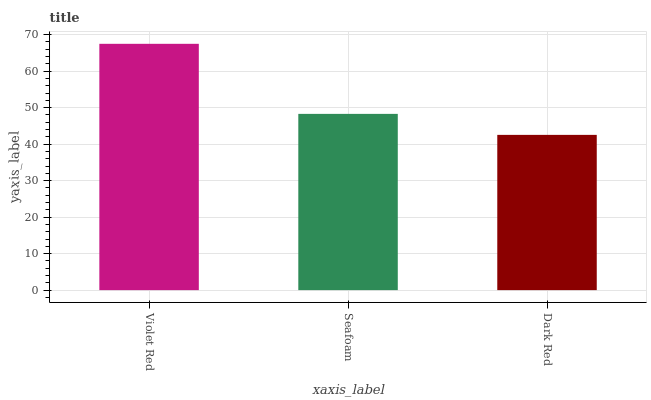Is Dark Red the minimum?
Answer yes or no. Yes. Is Violet Red the maximum?
Answer yes or no. Yes. Is Seafoam the minimum?
Answer yes or no. No. Is Seafoam the maximum?
Answer yes or no. No. Is Violet Red greater than Seafoam?
Answer yes or no. Yes. Is Seafoam less than Violet Red?
Answer yes or no. Yes. Is Seafoam greater than Violet Red?
Answer yes or no. No. Is Violet Red less than Seafoam?
Answer yes or no. No. Is Seafoam the high median?
Answer yes or no. Yes. Is Seafoam the low median?
Answer yes or no. Yes. Is Violet Red the high median?
Answer yes or no. No. Is Violet Red the low median?
Answer yes or no. No. 